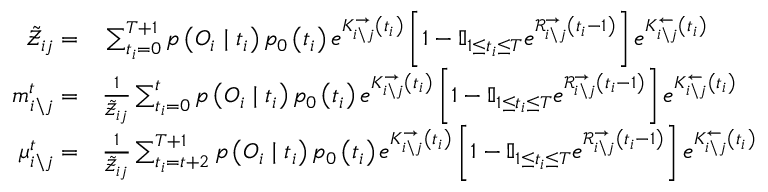Convert formula to latex. <formula><loc_0><loc_0><loc_500><loc_500>\begin{array} { r l } { \tilde { \mathcal { Z } } _ { i j } = } & \sum _ { t _ { i } = 0 } ^ { T + 1 } p \left ( O _ { i } | t _ { i } \right ) p _ { 0 } \left ( t _ { i } \right ) e ^ { K _ { i \ j } ^ { \rightarrow } \left ( t _ { i } \right ) } \left [ 1 - \mathbb { I } _ { 1 \leq t _ { i } \leq T } e ^ { \mathcal { R } _ { i \ j } ^ { \rightarrow } \left ( t _ { i } - 1 \right ) } \right ] e ^ { K _ { i \ j } ^ { \leftarrow } \left ( t _ { i } \right ) } } \\ { m _ { i \ j } ^ { t } = } & \frac { 1 } { \tilde { \mathcal { Z } } _ { i j } } \sum _ { t _ { i } = 0 } ^ { t } p \left ( O _ { i } | t _ { i } \right ) p _ { 0 } \left ( t _ { i } \right ) e ^ { K _ { i \ j } ^ { \rightarrow } \left ( t _ { i } \right ) } \left [ 1 - \mathbb { I } _ { 1 \leq t _ { i } \leq T } e ^ { \mathcal { R } _ { i \ j } ^ { \rightarrow } \left ( t _ { i } - 1 \right ) } \right ] e ^ { K _ { i \ j } ^ { \leftarrow } \left ( t _ { i } \right ) } } \\ { \mu _ { i \ j } ^ { t } = } & \frac { 1 } { \tilde { \mathcal { Z } } _ { i j } } \sum _ { t _ { i } = t + 2 } ^ { T + 1 } p \left ( O _ { i } | t _ { i } \right ) p _ { 0 } \left ( t _ { i } \right ) e ^ { K _ { i \ j } ^ { \rightarrow } \left ( t _ { i } \right ) } \left [ 1 - \mathbb { I } _ { 1 \leq t _ { i } \leq T } e ^ { \mathcal { R } _ { i \ j } ^ { \rightarrow } \left ( t _ { i } - 1 \right ) } \right ] e ^ { K _ { i \ j } ^ { \leftarrow } \left ( t _ { i } \right ) } } \end{array}</formula> 